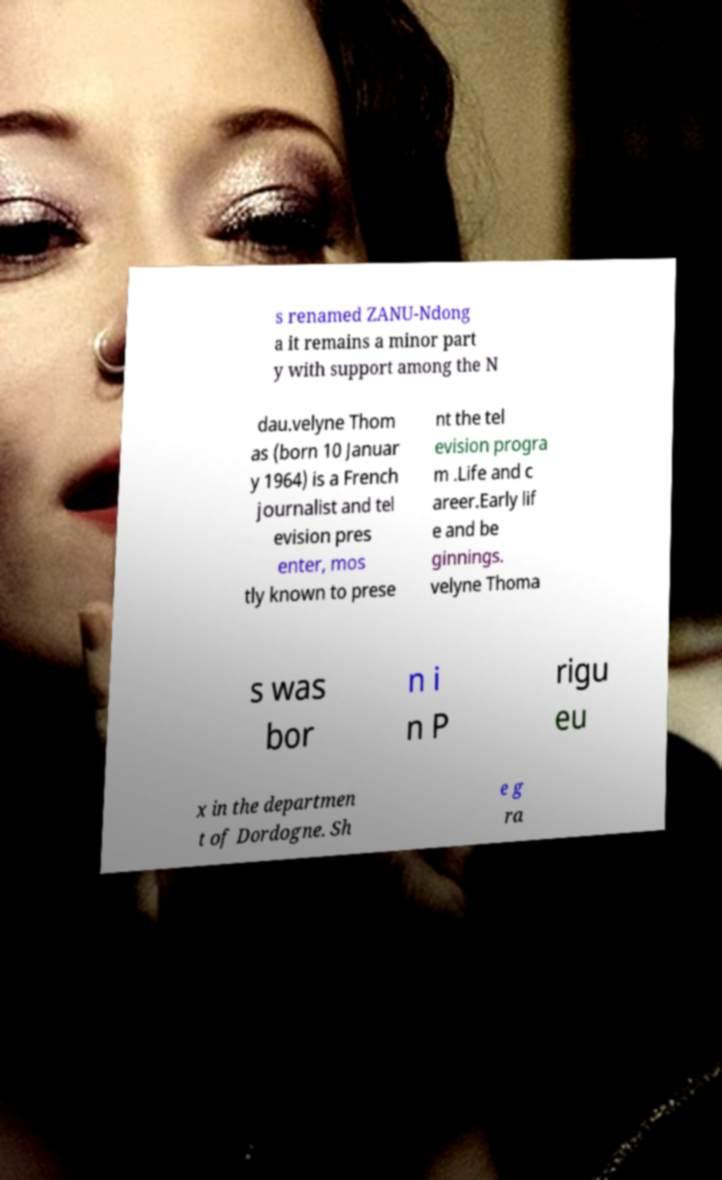Please identify and transcribe the text found in this image. s renamed ZANU-Ndong a it remains a minor part y with support among the N dau.velyne Thom as (born 10 Januar y 1964) is a French journalist and tel evision pres enter, mos tly known to prese nt the tel evision progra m .Life and c areer.Early lif e and be ginnings. velyne Thoma s was bor n i n P rigu eu x in the departmen t of Dordogne. Sh e g ra 